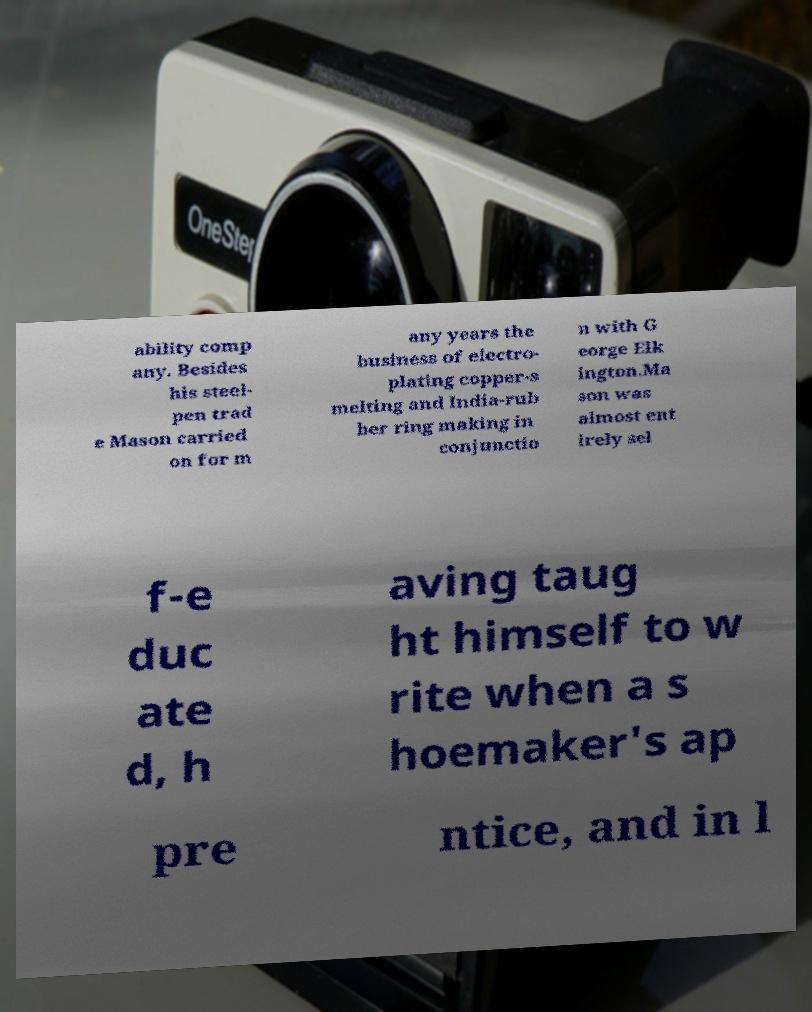Please identify and transcribe the text found in this image. ability comp any. Besides his steel- pen trad e Mason carried on for m any years the business of electro- plating copper-s melting and India-rub ber ring making in conjunctio n with G eorge Elk ington.Ma son was almost ent irely sel f-e duc ate d, h aving taug ht himself to w rite when a s hoemaker's ap pre ntice, and in l 